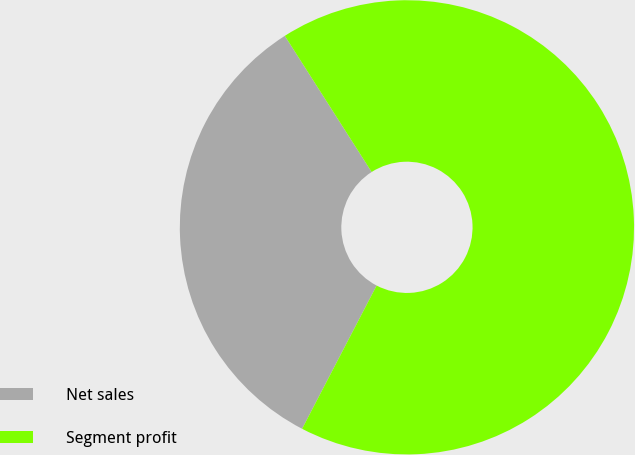Convert chart. <chart><loc_0><loc_0><loc_500><loc_500><pie_chart><fcel>Net sales<fcel>Segment profit<nl><fcel>33.33%<fcel>66.67%<nl></chart> 